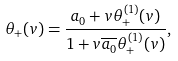Convert formula to latex. <formula><loc_0><loc_0><loc_500><loc_500>\theta _ { + } ( v ) = \frac { a _ { 0 } + v \theta _ { + } ^ { ( 1 ) } ( v ) } { 1 + v \overline { a _ { 0 } } \theta _ { + } ^ { ( 1 ) } ( v ) } ,</formula> 